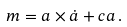Convert formula to latex. <formula><loc_0><loc_0><loc_500><loc_500>m = a \times \dot { a } + c a \, .</formula> 